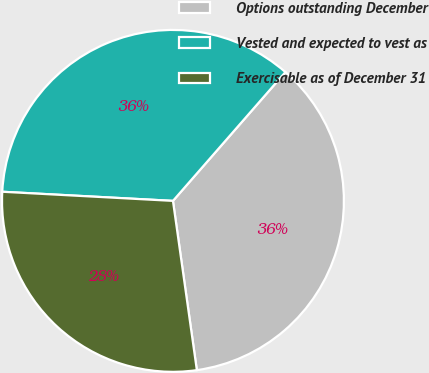Convert chart. <chart><loc_0><loc_0><loc_500><loc_500><pie_chart><fcel>Options outstanding December<fcel>Vested and expected to vest as<fcel>Exercisable as of December 31<nl><fcel>36.34%<fcel>35.57%<fcel>28.08%<nl></chart> 